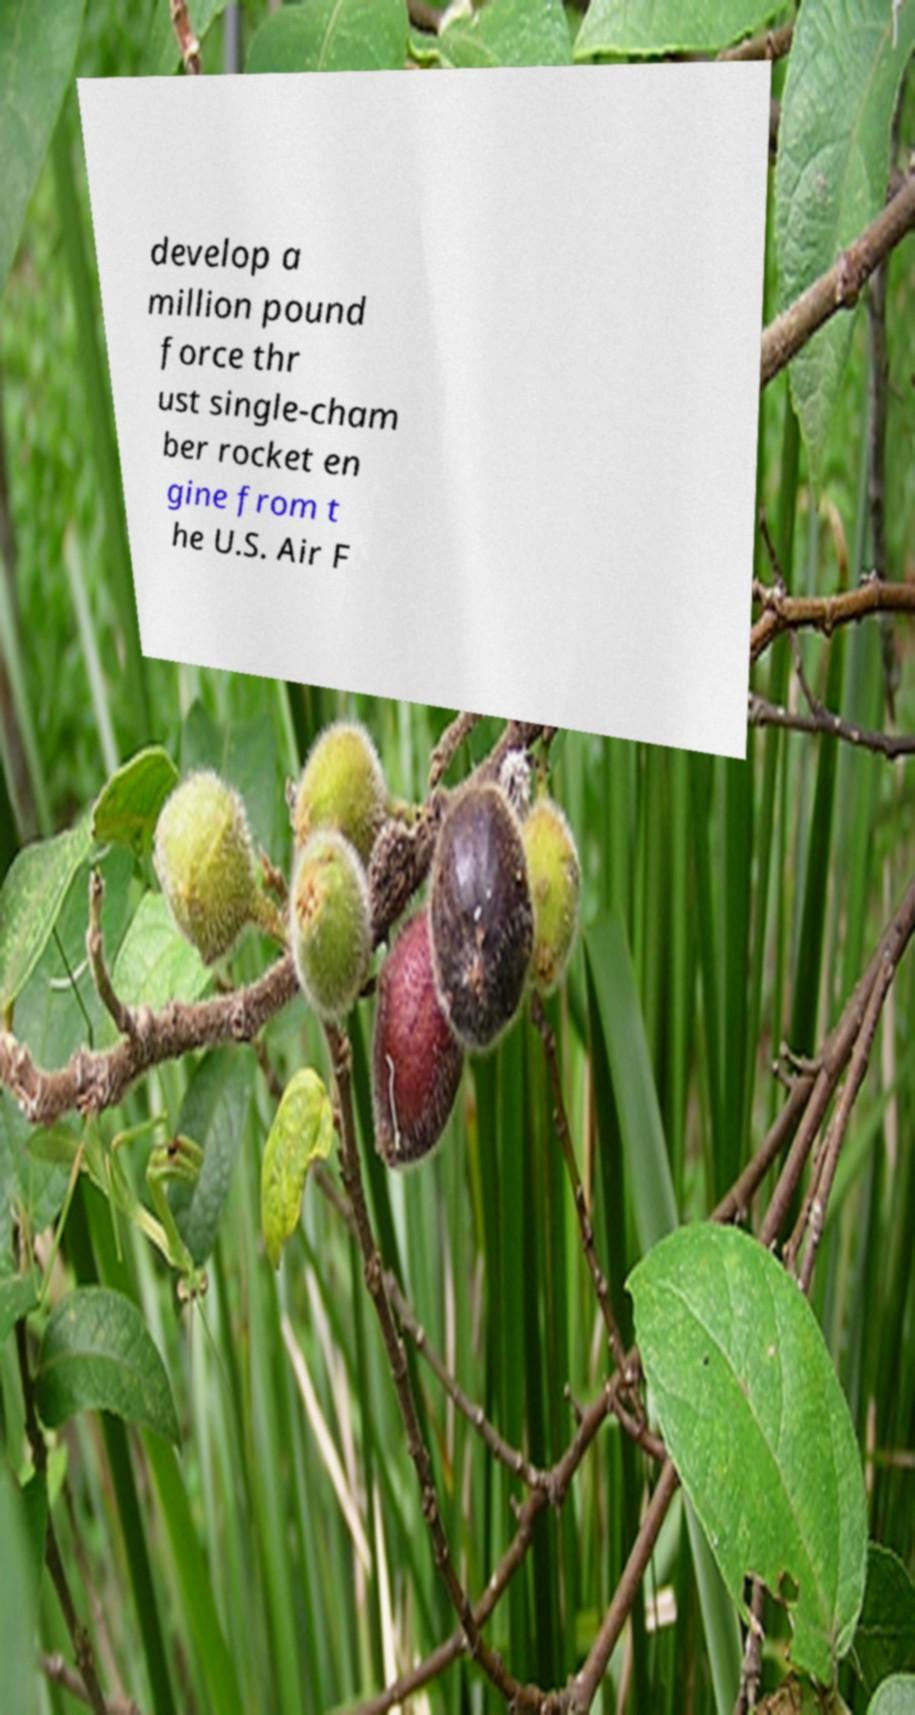Could you extract and type out the text from this image? develop a million pound force thr ust single-cham ber rocket en gine from t he U.S. Air F 